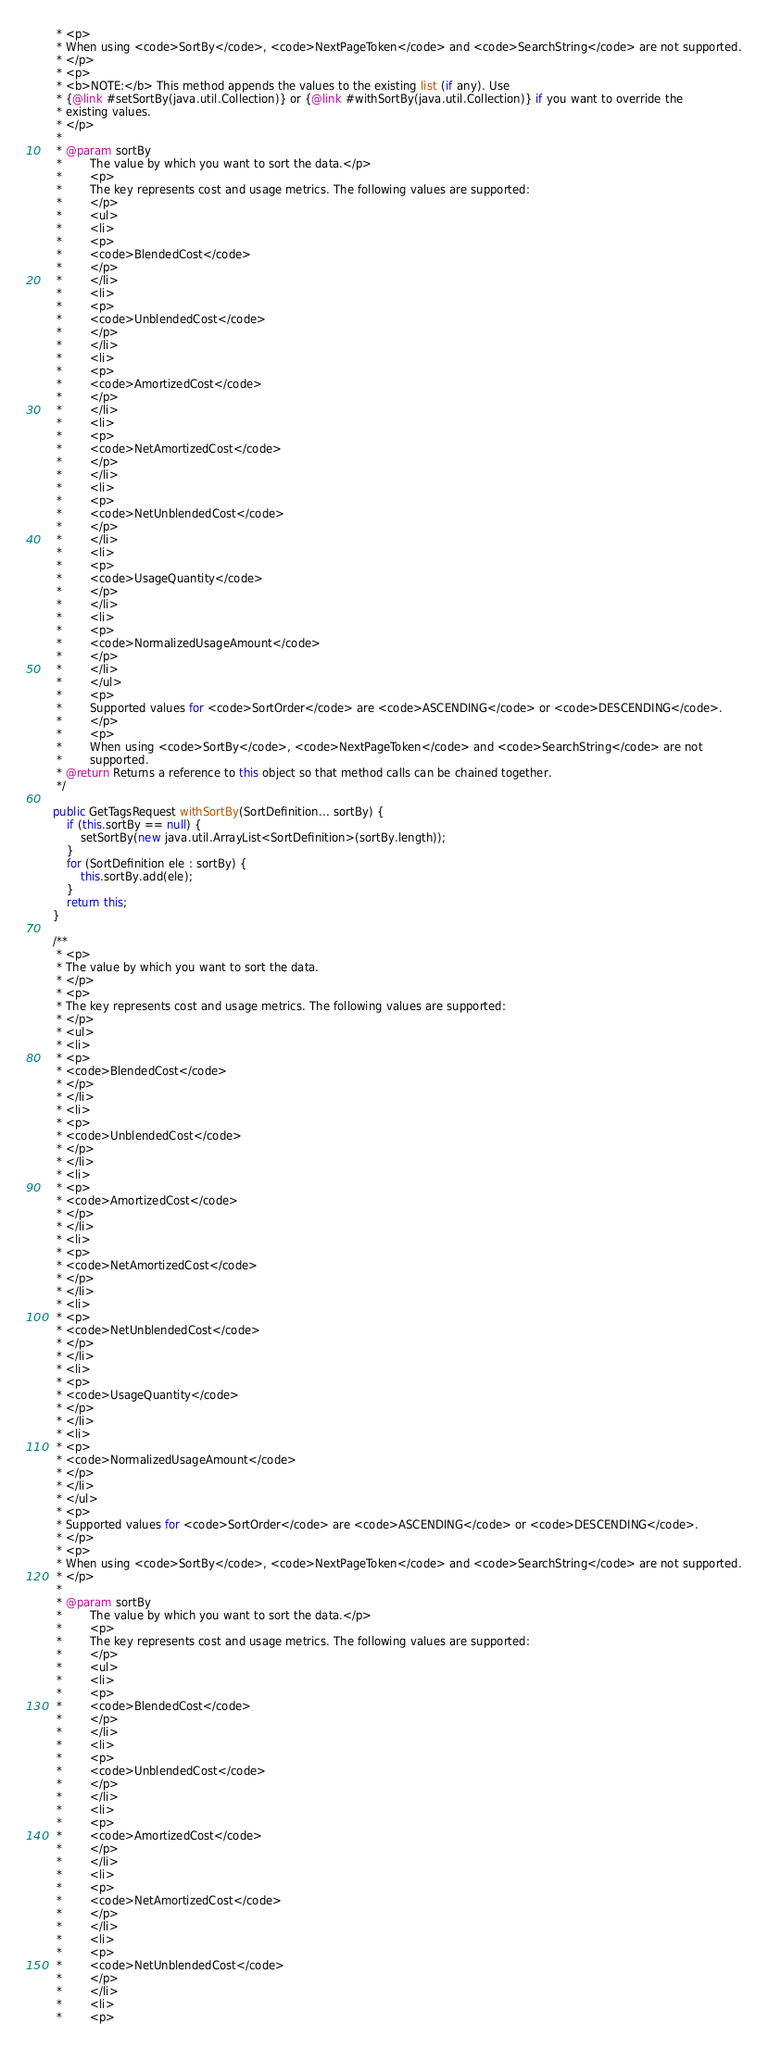Convert code to text. <code><loc_0><loc_0><loc_500><loc_500><_Java_>     * <p>
     * When using <code>SortBy</code>, <code>NextPageToken</code> and <code>SearchString</code> are not supported.
     * </p>
     * <p>
     * <b>NOTE:</b> This method appends the values to the existing list (if any). Use
     * {@link #setSortBy(java.util.Collection)} or {@link #withSortBy(java.util.Collection)} if you want to override the
     * existing values.
     * </p>
     * 
     * @param sortBy
     *        The value by which you want to sort the data.</p>
     *        <p>
     *        The key represents cost and usage metrics. The following values are supported:
     *        </p>
     *        <ul>
     *        <li>
     *        <p>
     *        <code>BlendedCost</code>
     *        </p>
     *        </li>
     *        <li>
     *        <p>
     *        <code>UnblendedCost</code>
     *        </p>
     *        </li>
     *        <li>
     *        <p>
     *        <code>AmortizedCost</code>
     *        </p>
     *        </li>
     *        <li>
     *        <p>
     *        <code>NetAmortizedCost</code>
     *        </p>
     *        </li>
     *        <li>
     *        <p>
     *        <code>NetUnblendedCost</code>
     *        </p>
     *        </li>
     *        <li>
     *        <p>
     *        <code>UsageQuantity</code>
     *        </p>
     *        </li>
     *        <li>
     *        <p>
     *        <code>NormalizedUsageAmount</code>
     *        </p>
     *        </li>
     *        </ul>
     *        <p>
     *        Supported values for <code>SortOrder</code> are <code>ASCENDING</code> or <code>DESCENDING</code>.
     *        </p>
     *        <p>
     *        When using <code>SortBy</code>, <code>NextPageToken</code> and <code>SearchString</code> are not
     *        supported.
     * @return Returns a reference to this object so that method calls can be chained together.
     */

    public GetTagsRequest withSortBy(SortDefinition... sortBy) {
        if (this.sortBy == null) {
            setSortBy(new java.util.ArrayList<SortDefinition>(sortBy.length));
        }
        for (SortDefinition ele : sortBy) {
            this.sortBy.add(ele);
        }
        return this;
    }

    /**
     * <p>
     * The value by which you want to sort the data.
     * </p>
     * <p>
     * The key represents cost and usage metrics. The following values are supported:
     * </p>
     * <ul>
     * <li>
     * <p>
     * <code>BlendedCost</code>
     * </p>
     * </li>
     * <li>
     * <p>
     * <code>UnblendedCost</code>
     * </p>
     * </li>
     * <li>
     * <p>
     * <code>AmortizedCost</code>
     * </p>
     * </li>
     * <li>
     * <p>
     * <code>NetAmortizedCost</code>
     * </p>
     * </li>
     * <li>
     * <p>
     * <code>NetUnblendedCost</code>
     * </p>
     * </li>
     * <li>
     * <p>
     * <code>UsageQuantity</code>
     * </p>
     * </li>
     * <li>
     * <p>
     * <code>NormalizedUsageAmount</code>
     * </p>
     * </li>
     * </ul>
     * <p>
     * Supported values for <code>SortOrder</code> are <code>ASCENDING</code> or <code>DESCENDING</code>.
     * </p>
     * <p>
     * When using <code>SortBy</code>, <code>NextPageToken</code> and <code>SearchString</code> are not supported.
     * </p>
     * 
     * @param sortBy
     *        The value by which you want to sort the data.</p>
     *        <p>
     *        The key represents cost and usage metrics. The following values are supported:
     *        </p>
     *        <ul>
     *        <li>
     *        <p>
     *        <code>BlendedCost</code>
     *        </p>
     *        </li>
     *        <li>
     *        <p>
     *        <code>UnblendedCost</code>
     *        </p>
     *        </li>
     *        <li>
     *        <p>
     *        <code>AmortizedCost</code>
     *        </p>
     *        </li>
     *        <li>
     *        <p>
     *        <code>NetAmortizedCost</code>
     *        </p>
     *        </li>
     *        <li>
     *        <p>
     *        <code>NetUnblendedCost</code>
     *        </p>
     *        </li>
     *        <li>
     *        <p></code> 